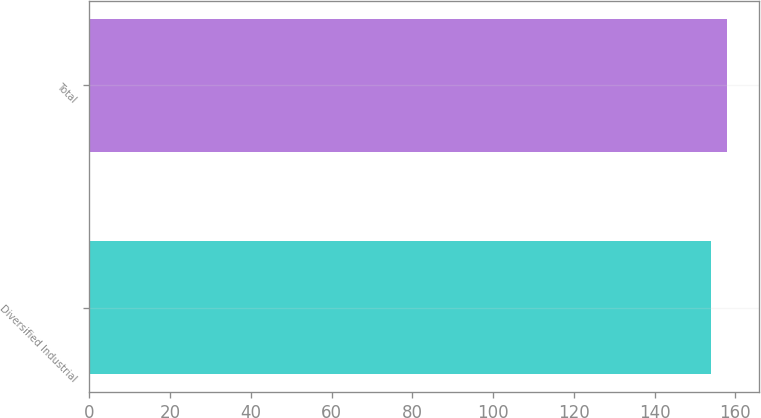Convert chart to OTSL. <chart><loc_0><loc_0><loc_500><loc_500><bar_chart><fcel>Diversified Industrial<fcel>Total<nl><fcel>154<fcel>158<nl></chart> 